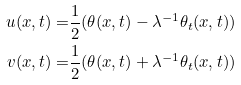<formula> <loc_0><loc_0><loc_500><loc_500>u ( x , t ) = & \frac { 1 } { 2 } ( \theta ( x , t ) - \lambda ^ { - 1 } \theta _ { t } ( x , t ) ) \\ v ( x , t ) = & \frac { 1 } { 2 } ( \theta ( x , t ) + \lambda ^ { - 1 } \theta _ { t } ( x , t ) )</formula> 